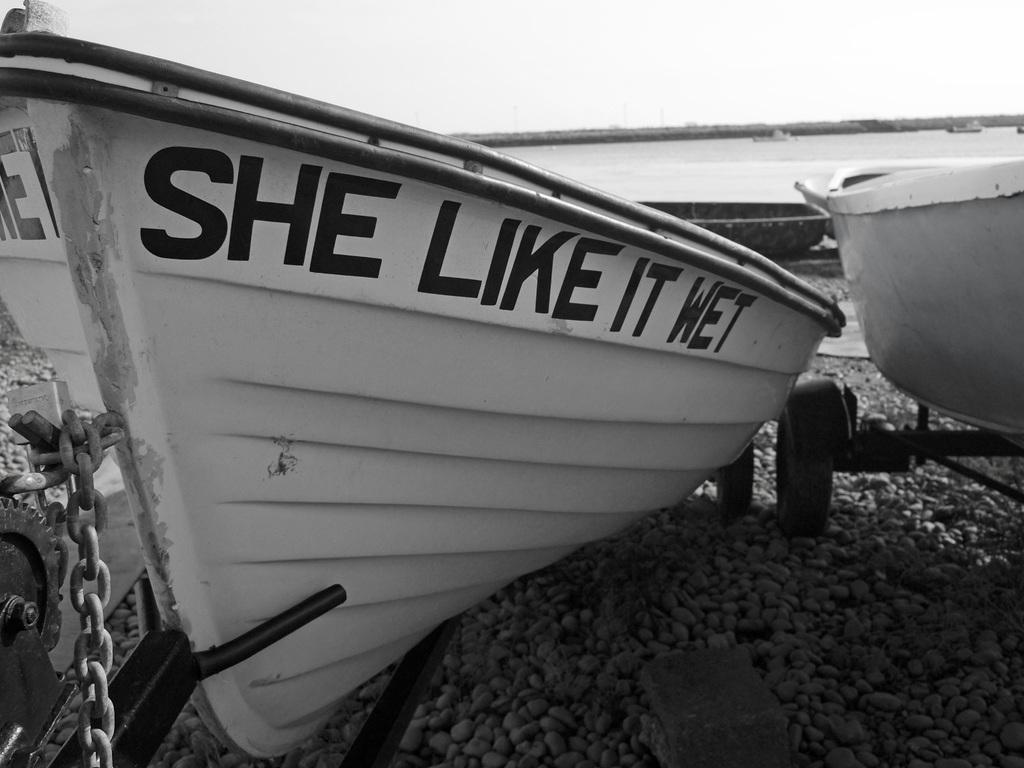What type of vehicles are in the image? There are boats in the image. Where are the boats located? The boats are on the water. What is the primary element visible in the image? Water is visible in the image. What is at the bottom of the image? There are stones at the bottom of the image. What can be seen in the background of the image? The sky is visible in the background of the image. Can you see a zebra grazing on the hill in the image? There is no zebra or hill present in the image; it features boats on the water with a sky background. 